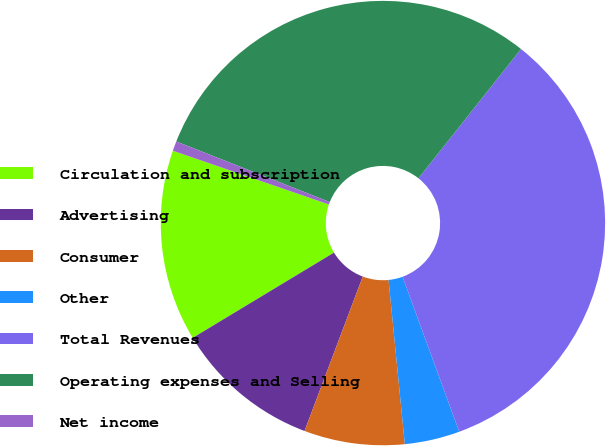Convert chart. <chart><loc_0><loc_0><loc_500><loc_500><pie_chart><fcel>Circulation and subscription<fcel>Advertising<fcel>Consumer<fcel>Other<fcel>Total Revenues<fcel>Operating expenses and Selling<fcel>Net income<nl><fcel>13.92%<fcel>10.62%<fcel>7.31%<fcel>4.01%<fcel>33.75%<fcel>29.69%<fcel>0.71%<nl></chart> 